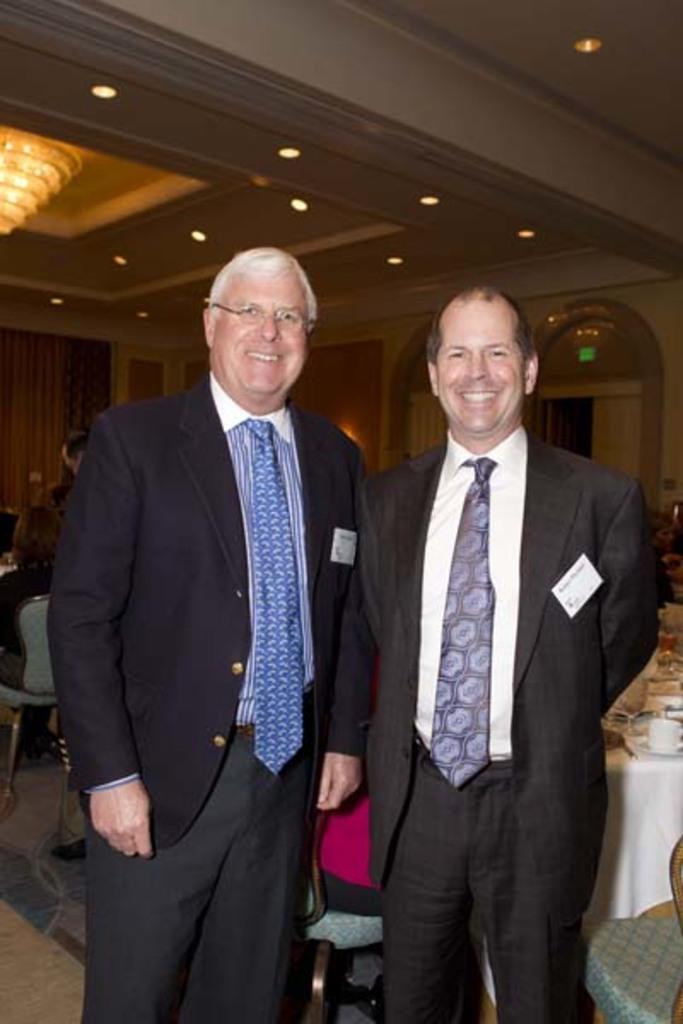Describe this image in one or two sentences. In this image, there are two men standing and smiling. On the right side of the image, I can see a table covered with a cloth and few things are placed on it. This looks like a chair. On the left side of the image, I can see a person sitting in the chair. These are the ceiling lights, which are attached to the ceiling. I think this is a chandelier, which is hanging. 